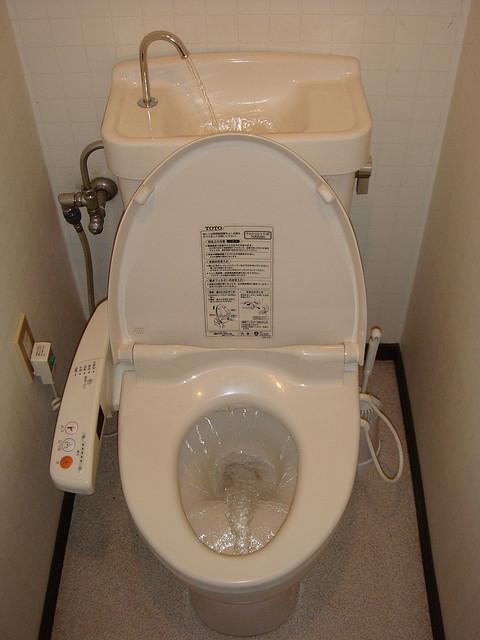Will this rinse your booty for you?
Be succinct. Yes. What is on the back of the toilet?
Answer briefly. Sink. Is there tile on the walls?
Be succinct. Yes. Can a person sit backwards, brush their teeth and go potty at the same time?
Write a very short answer. Yes. 